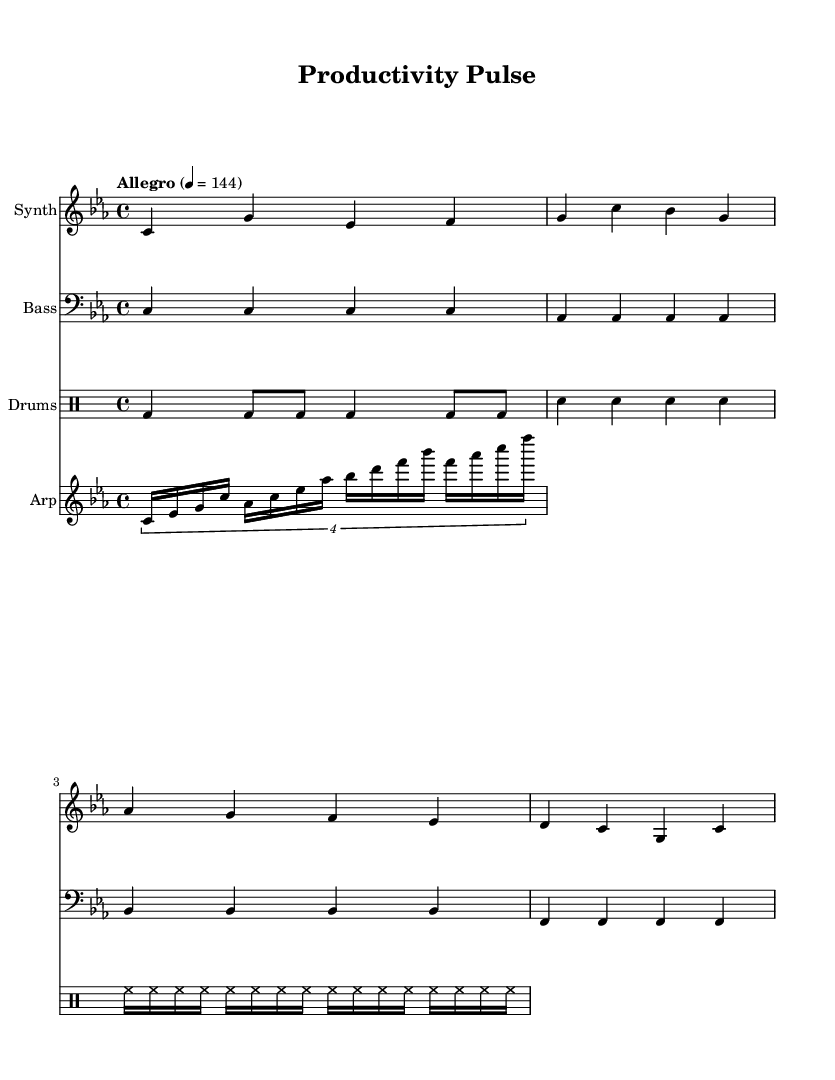What is the key signature of this music? The key signature is C minor, which has three flats. This can be identified by looking at the beginning of the staff where the flat symbols indicate the notes affected.
Answer: C minor What is the time signature of this music? The time signature is 4/4, which is indicated at the beginning of the sheet music. This means there are four beats in each measure.
Answer: 4/4 What is the tempo marking of this music? The tempo marking is "Allegro" at a speed of 144 beats per minute. This indicates a fast, lively tempo.
Answer: Allegro, 144 How many measures are in the synth part? The synth part consists of four measures, which can be counted by observing the vertical bar lines separating each measure in the staff.
Answer: Four Which instruments are included in this score? The score includes a Synth, Bass, Drums, and an Arpeggiator. This information can be found at the beginning of each staff, where the instrument name is specified.
Answer: Synth, Bass, Drums, Arpeggiator What type of rhythm is used for the drum part? The drum part uses a combination of quarter notes, eighth notes, and sixteenth notes. This can be identified by looking at the note durations indicated in the drum staff.
Answer: Combination What type of music is represented in this sheet? The music is fast-paced electronic music, which can be inferred from the tempo, use of synthesizers, and rhythmic patterns intended for productivity and focus.
Answer: Fast-paced electronic music 